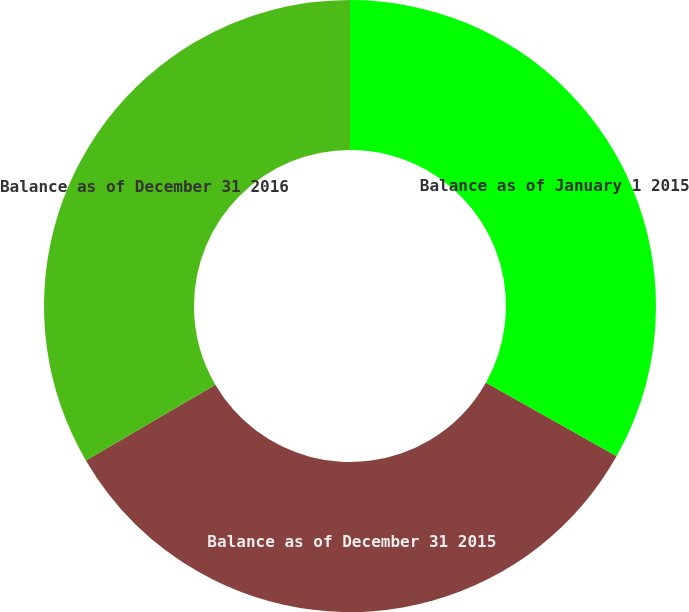Convert chart to OTSL. <chart><loc_0><loc_0><loc_500><loc_500><pie_chart><fcel>Balance as of January 1 2015<fcel>Balance as of December 31 2015<fcel>Balance as of December 31 2016<nl><fcel>33.17%<fcel>33.4%<fcel>33.42%<nl></chart> 